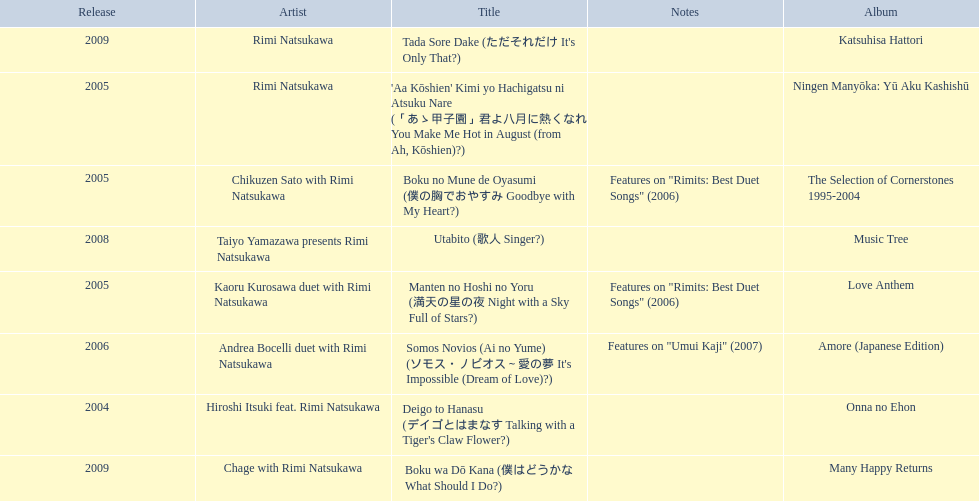What are all of the titles? Deigo to Hanasu (デイゴとはまなす Talking with a Tiger's Claw Flower?), Boku no Mune de Oyasumi (僕の胸でおやすみ Goodbye with My Heart?), 'Aa Kōshien' Kimi yo Hachigatsu ni Atsuku Nare (「あゝ甲子園」君よ八月に熱くなれ You Make Me Hot in August (from Ah, Kōshien)?), Manten no Hoshi no Yoru (満天の星の夜 Night with a Sky Full of Stars?), Somos Novios (Ai no Yume) (ソモス・ノビオス～愛の夢 It's Impossible (Dream of Love)?), Utabito (歌人 Singer?), Boku wa Dō Kana (僕はどうかな What Should I Do?), Tada Sore Dake (ただそれだけ It's Only That?). What are their notes? , Features on "Rimits: Best Duet Songs" (2006), , Features on "Rimits: Best Duet Songs" (2006), Features on "Umui Kaji" (2007), , , . Which title shares its notes with manten no hoshi no yoru (man tian noxing noye night with a sky full of stars?)? Boku no Mune de Oyasumi (僕の胸でおやすみ Goodbye with My Heart?). 